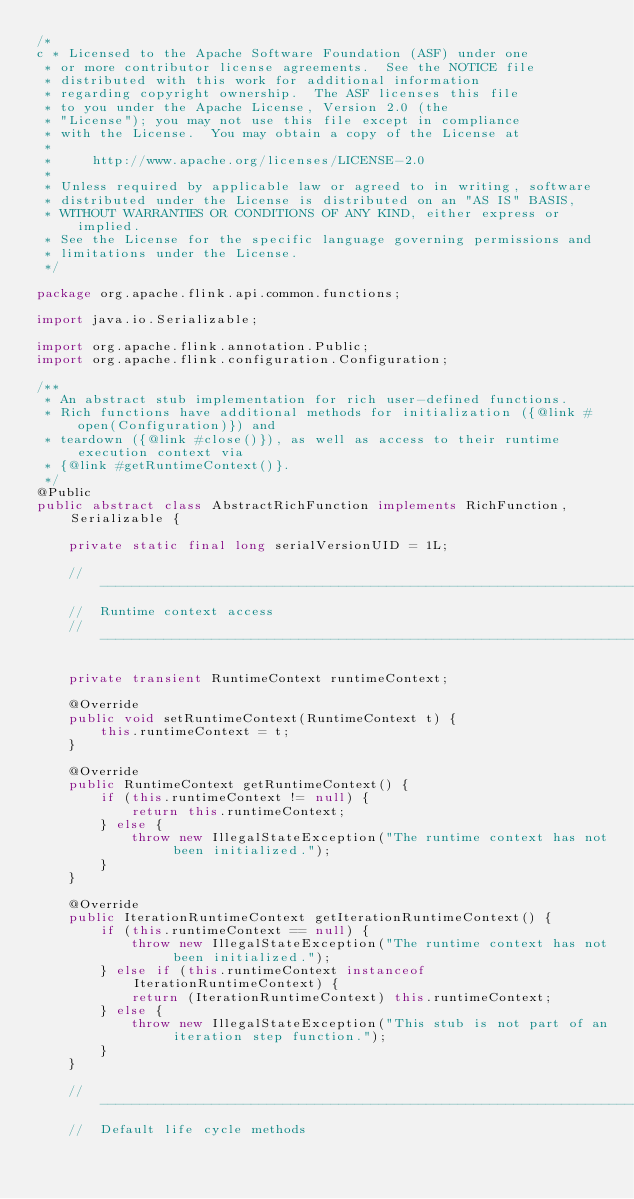Convert code to text. <code><loc_0><loc_0><loc_500><loc_500><_Java_>/*
c * Licensed to the Apache Software Foundation (ASF) under one
 * or more contributor license agreements.  See the NOTICE file
 * distributed with this work for additional information
 * regarding copyright ownership.  The ASF licenses this file
 * to you under the Apache License, Version 2.0 (the
 * "License"); you may not use this file except in compliance
 * with the License.  You may obtain a copy of the License at
 *
 *     http://www.apache.org/licenses/LICENSE-2.0
 *
 * Unless required by applicable law or agreed to in writing, software
 * distributed under the License is distributed on an "AS IS" BASIS,
 * WITHOUT WARRANTIES OR CONDITIONS OF ANY KIND, either express or implied.
 * See the License for the specific language governing permissions and
 * limitations under the License.
 */

package org.apache.flink.api.common.functions;

import java.io.Serializable;

import org.apache.flink.annotation.Public;
import org.apache.flink.configuration.Configuration;

/**
 * An abstract stub implementation for rich user-defined functions.
 * Rich functions have additional methods for initialization ({@link #open(Configuration)}) and
 * teardown ({@link #close()}), as well as access to their runtime execution context via
 * {@link #getRuntimeContext()}.
 */
@Public
public abstract class AbstractRichFunction implements RichFunction, Serializable {
	
	private static final long serialVersionUID = 1L;
	
	// --------------------------------------------------------------------------------------------
	//  Runtime context access
	// --------------------------------------------------------------------------------------------
	
	private transient RuntimeContext runtimeContext;

	@Override
	public void setRuntimeContext(RuntimeContext t) {
		this.runtimeContext = t;
	}

	@Override
	public RuntimeContext getRuntimeContext() {
		if (this.runtimeContext != null) {
			return this.runtimeContext;
		} else {
			throw new IllegalStateException("The runtime context has not been initialized.");
		}
	}
	
	@Override
	public IterationRuntimeContext getIterationRuntimeContext() {
		if (this.runtimeContext == null) {
			throw new IllegalStateException("The runtime context has not been initialized.");
		} else if (this.runtimeContext instanceof IterationRuntimeContext) {
			return (IterationRuntimeContext) this.runtimeContext;
		} else {
			throw new IllegalStateException("This stub is not part of an iteration step function.");
		}
	}
	
	// --------------------------------------------------------------------------------------------
	//  Default life cycle methods</code> 